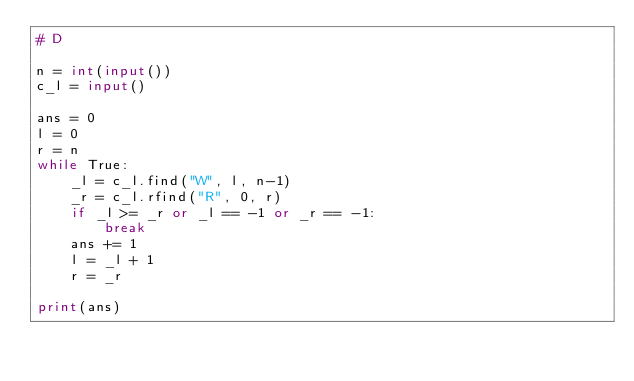<code> <loc_0><loc_0><loc_500><loc_500><_Python_># D

n = int(input())
c_l = input()

ans = 0
l = 0
r = n
while True:
    _l = c_l.find("W", l, n-1)
    _r = c_l.rfind("R", 0, r)
    if _l >= _r or _l == -1 or _r == -1:
        break
    ans += 1
    l = _l + 1
    r = _r

print(ans)

</code> 